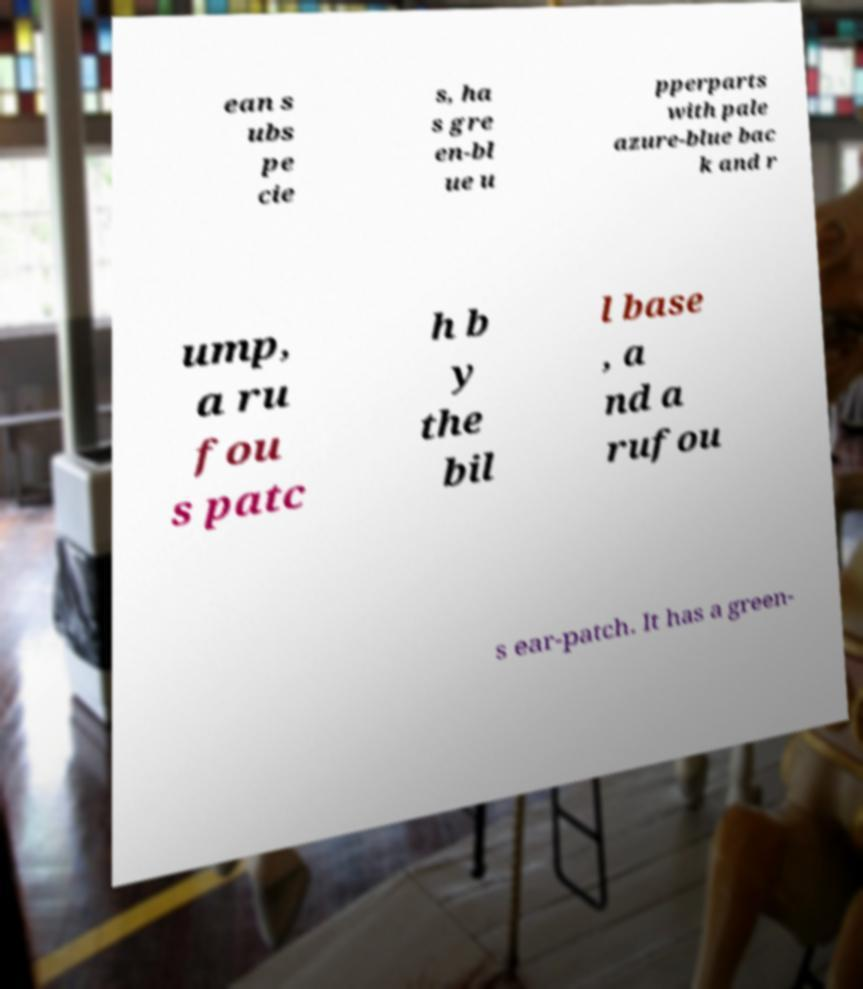There's text embedded in this image that I need extracted. Can you transcribe it verbatim? ean s ubs pe cie s, ha s gre en-bl ue u pperparts with pale azure-blue bac k and r ump, a ru fou s patc h b y the bil l base , a nd a rufou s ear-patch. It has a green- 